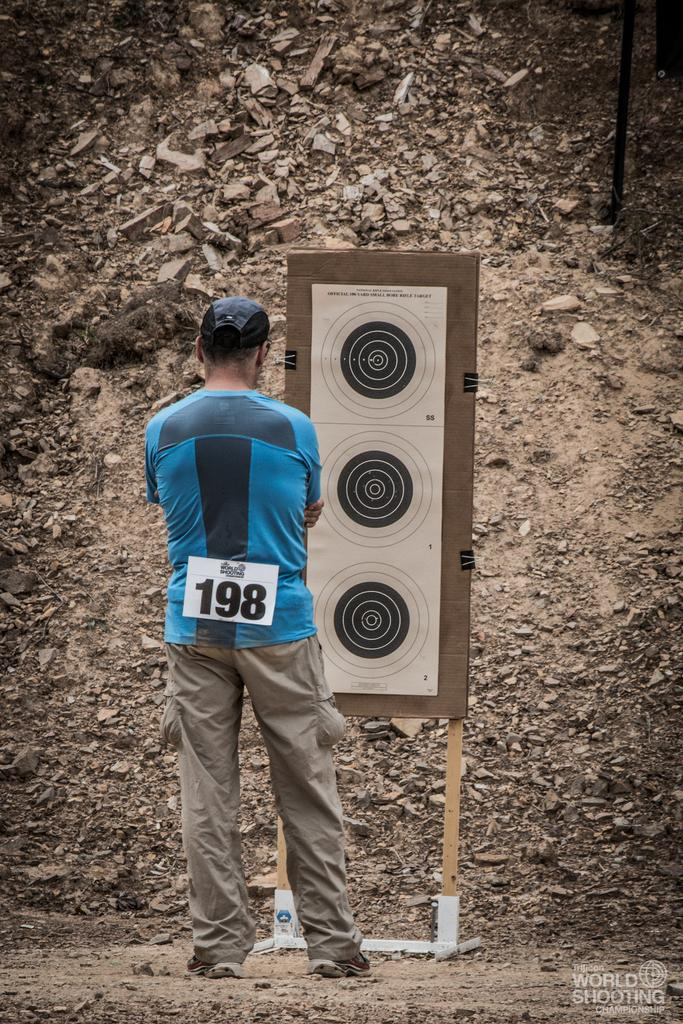What is the main subject of the image? There is a man standing in the image. What is in front of the man? There is a board in front of the man. What can be seen in the background of the image? There is a wall in the background of the image. What type of story is being told by the air in the image? There is no air present in the image, and therefore no story can be told by it. 